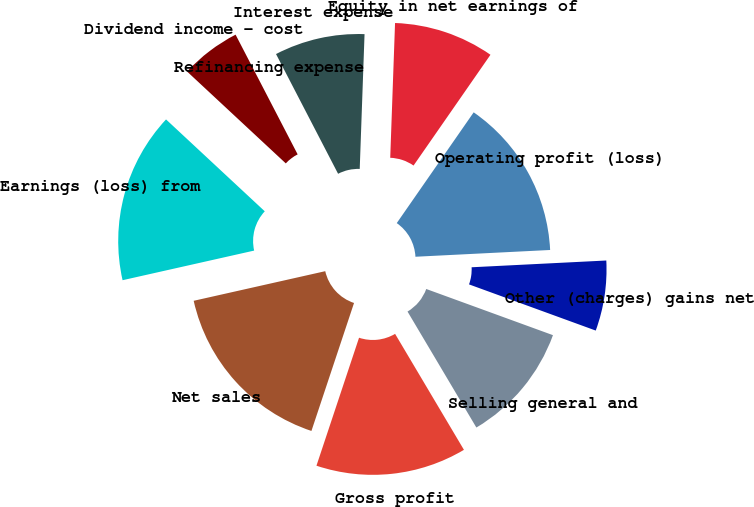Convert chart to OTSL. <chart><loc_0><loc_0><loc_500><loc_500><pie_chart><fcel>Net sales<fcel>Gross profit<fcel>Selling general and<fcel>Other (charges) gains net<fcel>Operating profit (loss)<fcel>Equity in net earnings of<fcel>Interest expense<fcel>Refinancing expense<fcel>Dividend income - cost<fcel>Earnings (loss) from<nl><fcel>16.36%<fcel>13.64%<fcel>10.91%<fcel>6.36%<fcel>14.54%<fcel>9.09%<fcel>8.18%<fcel>0.0%<fcel>5.46%<fcel>15.45%<nl></chart> 